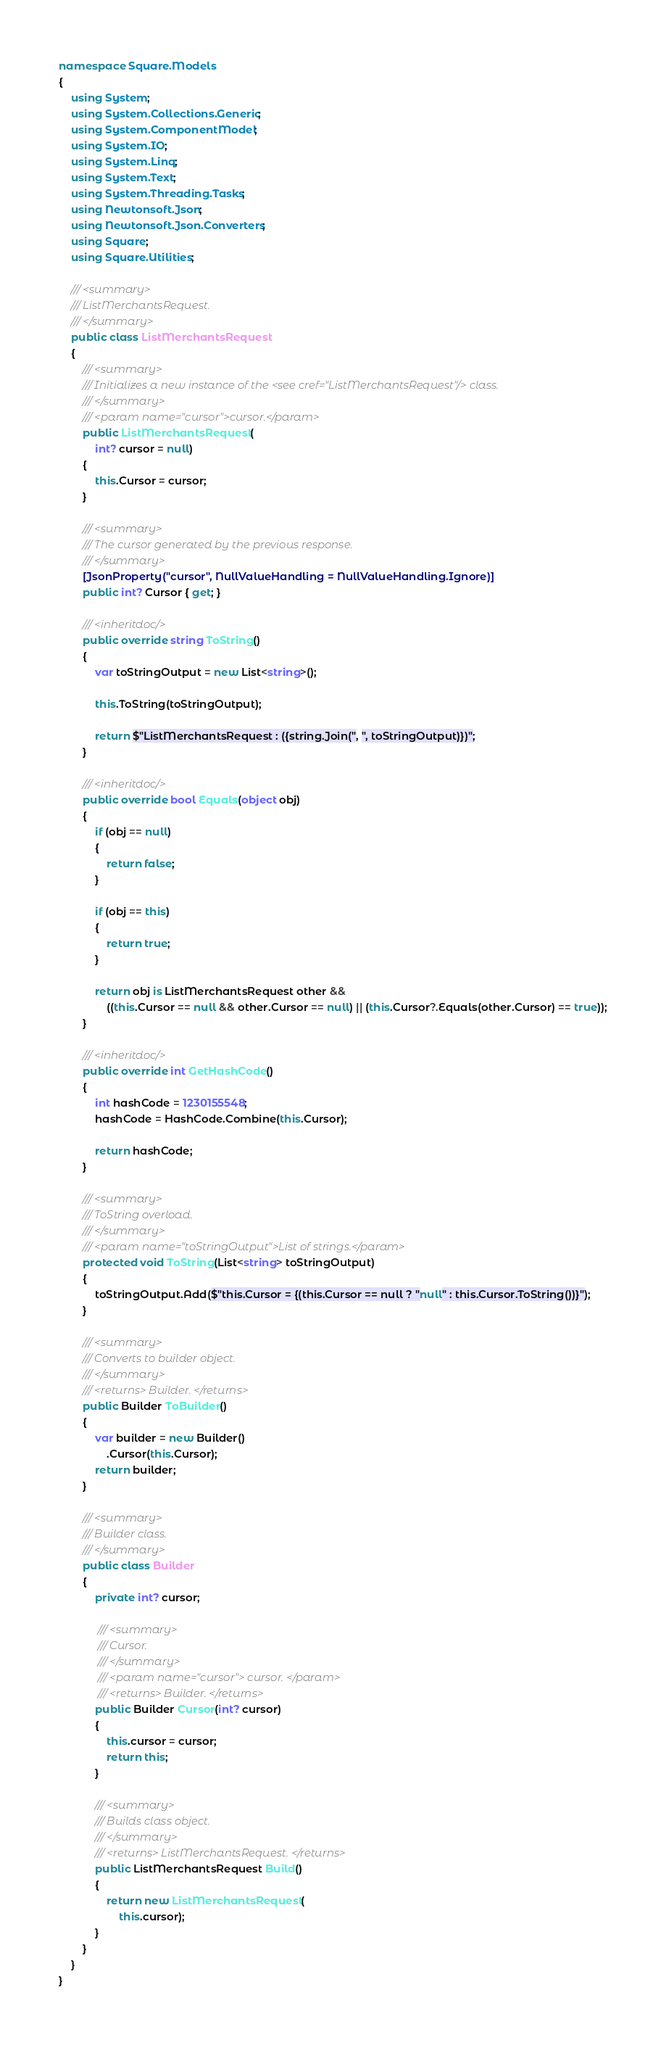<code> <loc_0><loc_0><loc_500><loc_500><_C#_>namespace Square.Models
{
    using System;
    using System.Collections.Generic;
    using System.ComponentModel;
    using System.IO;
    using System.Linq;
    using System.Text;
    using System.Threading.Tasks;
    using Newtonsoft.Json;
    using Newtonsoft.Json.Converters;
    using Square;
    using Square.Utilities;

    /// <summary>
    /// ListMerchantsRequest.
    /// </summary>
    public class ListMerchantsRequest
    {
        /// <summary>
        /// Initializes a new instance of the <see cref="ListMerchantsRequest"/> class.
        /// </summary>
        /// <param name="cursor">cursor.</param>
        public ListMerchantsRequest(
            int? cursor = null)
        {
            this.Cursor = cursor;
        }

        /// <summary>
        /// The cursor generated by the previous response.
        /// </summary>
        [JsonProperty("cursor", NullValueHandling = NullValueHandling.Ignore)]
        public int? Cursor { get; }

        /// <inheritdoc/>
        public override string ToString()
        {
            var toStringOutput = new List<string>();

            this.ToString(toStringOutput);

            return $"ListMerchantsRequest : ({string.Join(", ", toStringOutput)})";
        }

        /// <inheritdoc/>
        public override bool Equals(object obj)
        {
            if (obj == null)
            {
                return false;
            }

            if (obj == this)
            {
                return true;
            }

            return obj is ListMerchantsRequest other &&
                ((this.Cursor == null && other.Cursor == null) || (this.Cursor?.Equals(other.Cursor) == true));
        }
        
        /// <inheritdoc/>
        public override int GetHashCode()
        {
            int hashCode = 1230155548;
            hashCode = HashCode.Combine(this.Cursor);

            return hashCode;
        }
  
        /// <summary>
        /// ToString overload.
        /// </summary>
        /// <param name="toStringOutput">List of strings.</param>
        protected void ToString(List<string> toStringOutput)
        {
            toStringOutput.Add($"this.Cursor = {(this.Cursor == null ? "null" : this.Cursor.ToString())}");
        }

        /// <summary>
        /// Converts to builder object.
        /// </summary>
        /// <returns> Builder. </returns>
        public Builder ToBuilder()
        {
            var builder = new Builder()
                .Cursor(this.Cursor);
            return builder;
        }

        /// <summary>
        /// Builder class.
        /// </summary>
        public class Builder
        {
            private int? cursor;

             /// <summary>
             /// Cursor.
             /// </summary>
             /// <param name="cursor"> cursor. </param>
             /// <returns> Builder. </returns>
            public Builder Cursor(int? cursor)
            {
                this.cursor = cursor;
                return this;
            }

            /// <summary>
            /// Builds class object.
            /// </summary>
            /// <returns> ListMerchantsRequest. </returns>
            public ListMerchantsRequest Build()
            {
                return new ListMerchantsRequest(
                    this.cursor);
            }
        }
    }
}</code> 